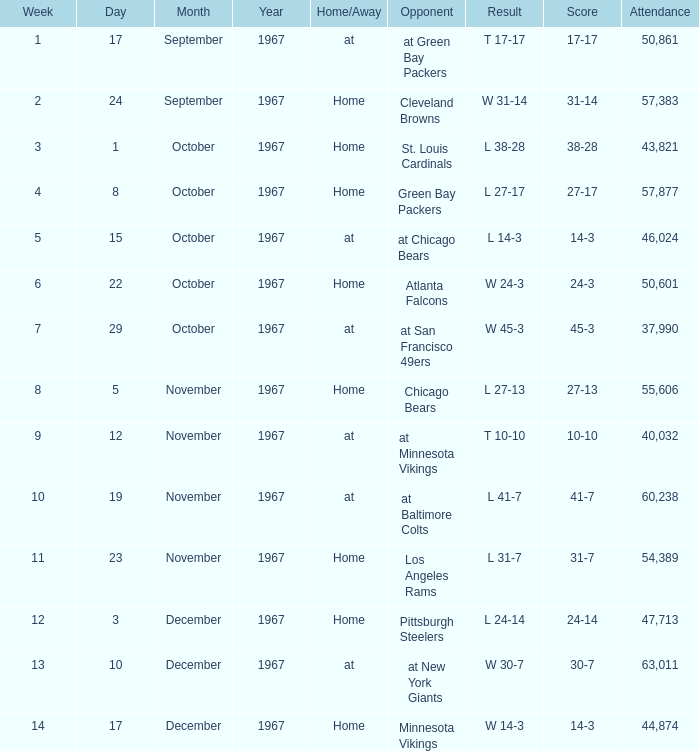Which Result has an Opponent of minnesota vikings? W 14-3. Write the full table. {'header': ['Week', 'Day', 'Month', 'Year', 'Home/Away', 'Opponent', 'Result', 'Score', 'Attendance'], 'rows': [['1', '17', 'September', '1967', 'at', 'at Green Bay Packers', 'T 17-17', '17-17', '50,861'], ['2', '24', 'September', '1967', 'Home', 'Cleveland Browns', 'W 31-14', '31-14', '57,383'], ['3', '1', 'October', '1967', 'Home', 'St. Louis Cardinals', 'L 38-28', '38-28', '43,821'], ['4', '8', 'October', '1967', 'Home', 'Green Bay Packers', 'L 27-17', '27-17', '57,877'], ['5', '15', 'October', '1967', 'at', 'at Chicago Bears', 'L 14-3', '14-3', '46,024'], ['6', '22', 'October', '1967', 'Home', 'Atlanta Falcons', 'W 24-3', '24-3', '50,601'], ['7', '29', 'October', '1967', 'at', 'at San Francisco 49ers', 'W 45-3', '45-3', '37,990'], ['8', '5', 'November', '1967', 'Home', 'Chicago Bears', 'L 27-13', '27-13', '55,606'], ['9', '12', 'November', '1967', 'at', 'at Minnesota Vikings', 'T 10-10', '10-10', '40,032'], ['10', '19', 'November', '1967', 'at', 'at Baltimore Colts', 'L 41-7', '41-7', '60,238'], ['11', '23', 'November', '1967', 'Home', 'Los Angeles Rams', 'L 31-7', '31-7', '54,389'], ['12', '3', 'December', '1967', 'Home', 'Pittsburgh Steelers', 'L 24-14', '24-14', '47,713'], ['13', '10', 'December', '1967', 'at', 'at New York Giants', 'W 30-7', '30-7', '63,011'], ['14', '17', 'December', '1967', 'Home', 'Minnesota Vikings', 'W 14-3', '14-3', '44,874']]} 